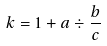<formula> <loc_0><loc_0><loc_500><loc_500>k = 1 + a \div \frac { b } { c }</formula> 